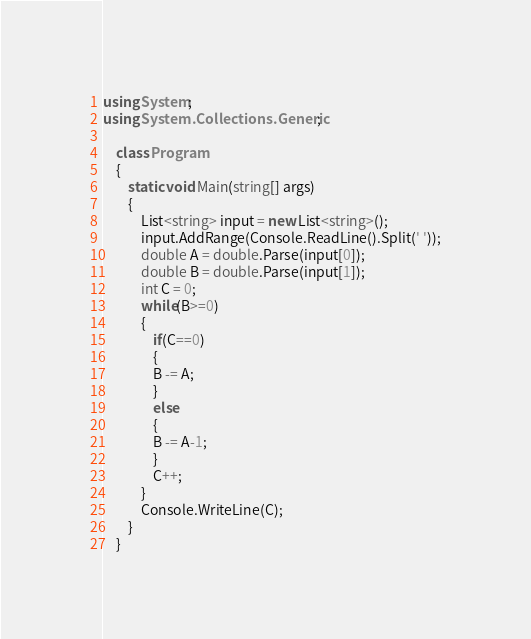Convert code to text. <code><loc_0><loc_0><loc_500><loc_500><_C#_>using System;
using System.Collections.Generic;

    class Program
    {
        static void Main(string[] args)
        {
            List<string> input = new List<string>();
            input.AddRange(Console.ReadLine().Split(' '));
            double A = double.Parse(input[0]);
            double B = double.Parse(input[1]);
            int C = 0;
            while(B>=0)
            {
                if(C==0)
                {
                B -= A;
                }
                else
                {
                B -= A-1;
                }
                C++;
            }
            Console.WriteLine(C);
        }
    }
</code> 